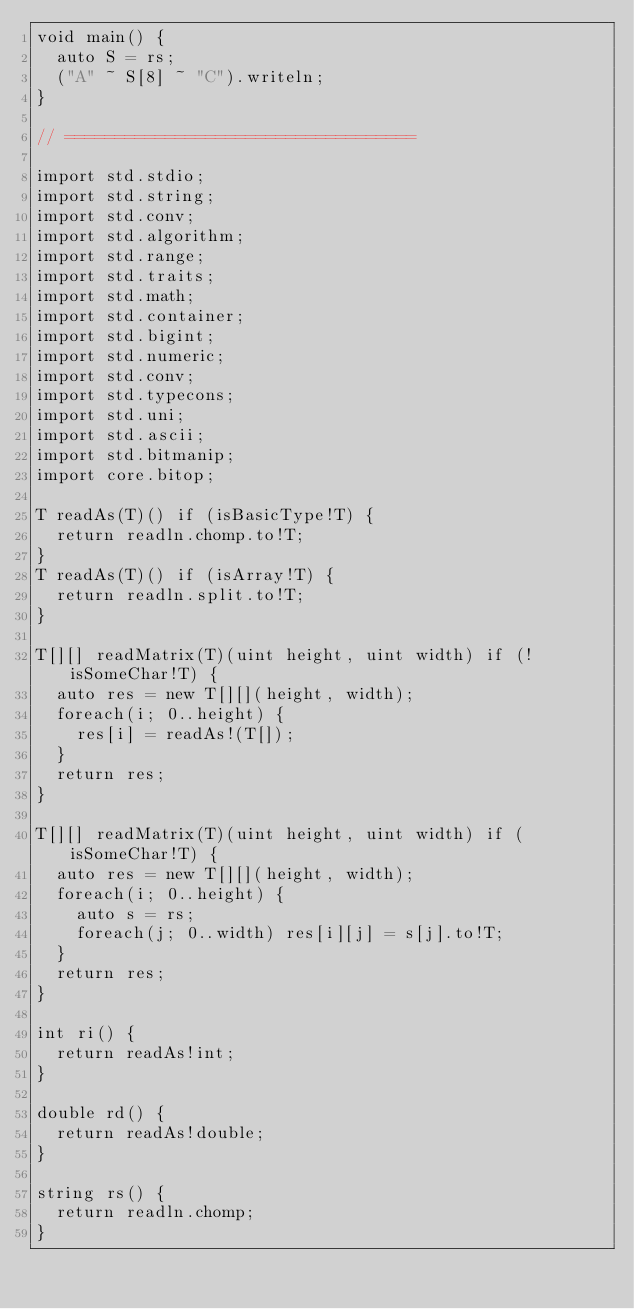Convert code to text. <code><loc_0><loc_0><loc_500><loc_500><_D_>void main() {
	auto S = rs;
	("A" ~ S[8] ~ "C").writeln;
}

// ===================================

import std.stdio;
import std.string;
import std.conv;
import std.algorithm;
import std.range;
import std.traits;
import std.math;
import std.container;
import std.bigint;
import std.numeric;
import std.conv;
import std.typecons;
import std.uni;
import std.ascii;
import std.bitmanip;
import core.bitop;

T readAs(T)() if (isBasicType!T) {
	return readln.chomp.to!T;
}
T readAs(T)() if (isArray!T) {
	return readln.split.to!T;
}

T[][] readMatrix(T)(uint height, uint width) if (!isSomeChar!T) {
	auto res = new T[][](height, width);
	foreach(i; 0..height) {
		res[i] = readAs!(T[]);
	}
	return res;
}

T[][] readMatrix(T)(uint height, uint width) if (isSomeChar!T) {
	auto res = new T[][](height, width);
	foreach(i; 0..height) {
		auto s = rs;
		foreach(j; 0..width) res[i][j] = s[j].to!T;
	}
	return res;
}

int ri() {
	return readAs!int;
}

double rd() {
	return readAs!double;
}

string rs() {
	return readln.chomp;
}</code> 